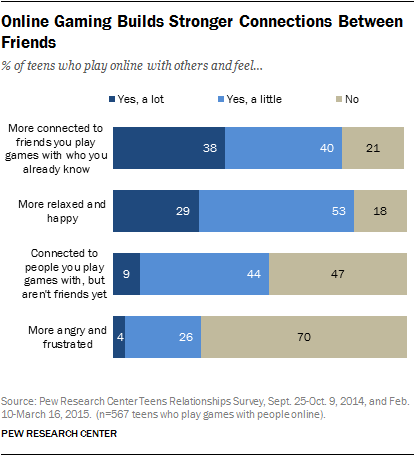Point out several critical features in this image. The option that most people choose "no" to is one that elicits feelings of anger and frustration. Approximately 2 out of every 4 people choose 'no' option when there are more than 40% of options available in the survey. 